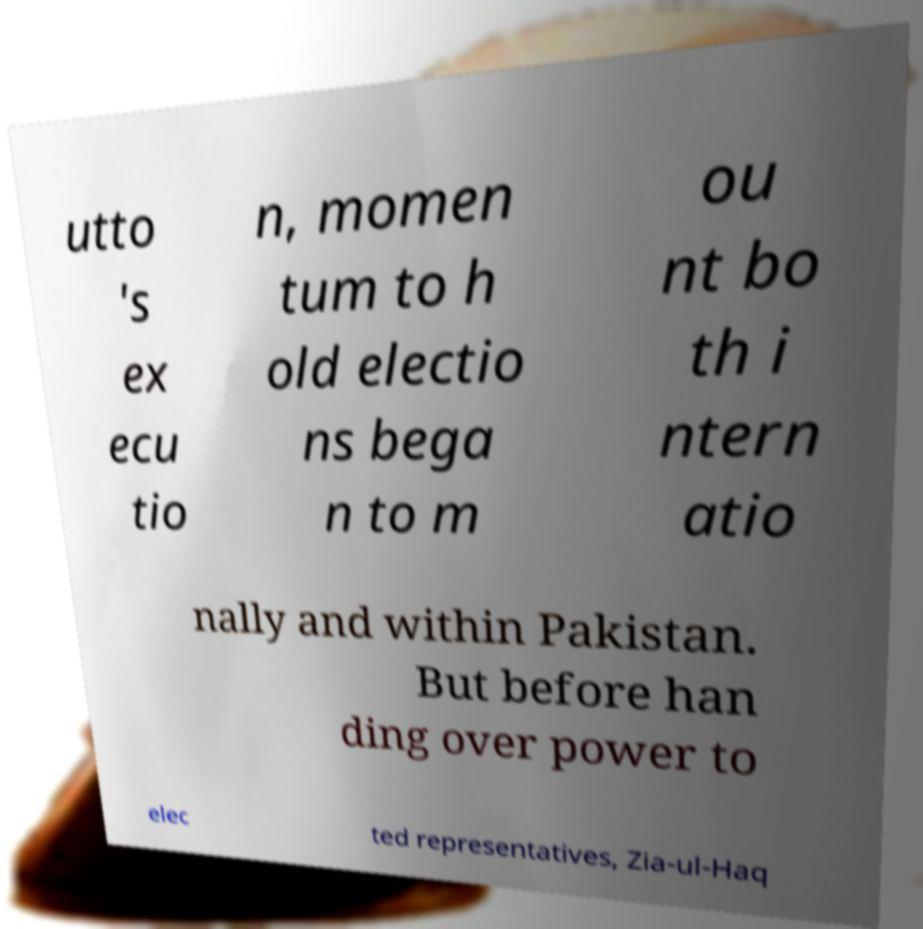Please identify and transcribe the text found in this image. utto 's ex ecu tio n, momen tum to h old electio ns bega n to m ou nt bo th i ntern atio nally and within Pakistan. But before han ding over power to elec ted representatives, Zia-ul-Haq 